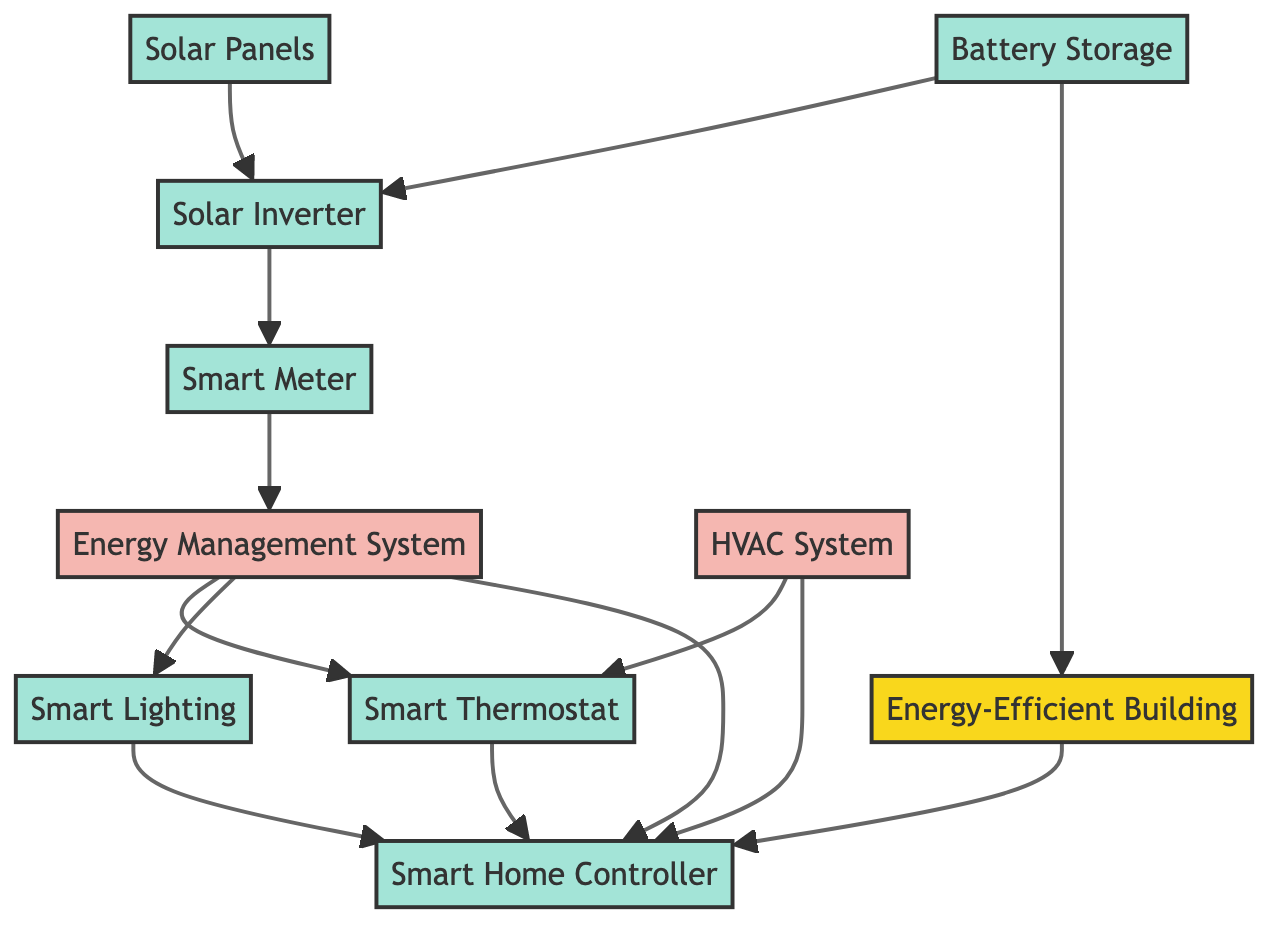What is the total number of nodes in the diagram? The diagram contains ten nodes: Energy-Efficient Building, Smart Thermostat, Solar Panels, Solar Inverter, Smart Lighting, Smart Meter, Energy Management System, HVAC System, Battery Storage, and Smart Home Controller. Counting all these gives a total of ten.
Answer: ten Which device is directly connected to the Smart Thermostat? The Smart Thermostat is directly connected to the HVAC System as indicated by the connection arrows.
Answer: HVAC System What type of system is the Energy Management System? The Energy Management System is classified as a system in the diagram, which distinguishes it from devices and buildings based on the visual coding.
Answer: system How many devices are connected to the Smart Home Controller? The Smart Home Controller is connected to four devices: Smart Thermostat, Smart Lighting, Energy Management System, and HVAC System. Counting these connections reveals that there are four devices.
Answer: four What does the Solar Inverter connect to? The Solar Inverter has connections to both the Solar Panels and the Smart Meter as shown by the arrows leading from the Solar Inverter to these two nodes.
Answer: Solar Panels and Smart Meter Which node serves as a hub for controlling several other smart devices? The Smart Home Controller is specifically highlighted as a hub in the diagram, indicating its role in interconnecting various smart devices.
Answer: Smart Home Controller What is the role of the Smart Meter in the integration of smart home systems? The Smart Meter's role is to provide real-time energy usage data to the Energy Management System, which then optimizes energy usage in the building; it connects directly to those nodes, making this clear.
Answer: provide real-time energy usage data How do Battery Storage and Solar Panels interact in the diagram? The interaction is represented by a directional connection from Battery Storage to Solar Inverter, indicating that Battery Storage stores energy, which is then utilized by the Solar Inverter.
Answer: stores energy for later use Which two devices improve energy efficiency through lighting? The devices that improve energy efficiency through lighting are Smart Lighting and Smart Home Controller, as Smart Lighting can be programmed and controlled by the Smart Home Controller.
Answer: Smart Lighting and Smart Home Controller 